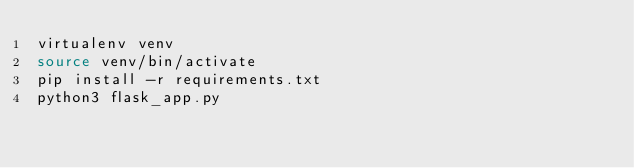Convert code to text. <code><loc_0><loc_0><loc_500><loc_500><_Bash_>virtualenv venv
source venv/bin/activate
pip install -r requirements.txt
python3 flask_app.py
</code> 